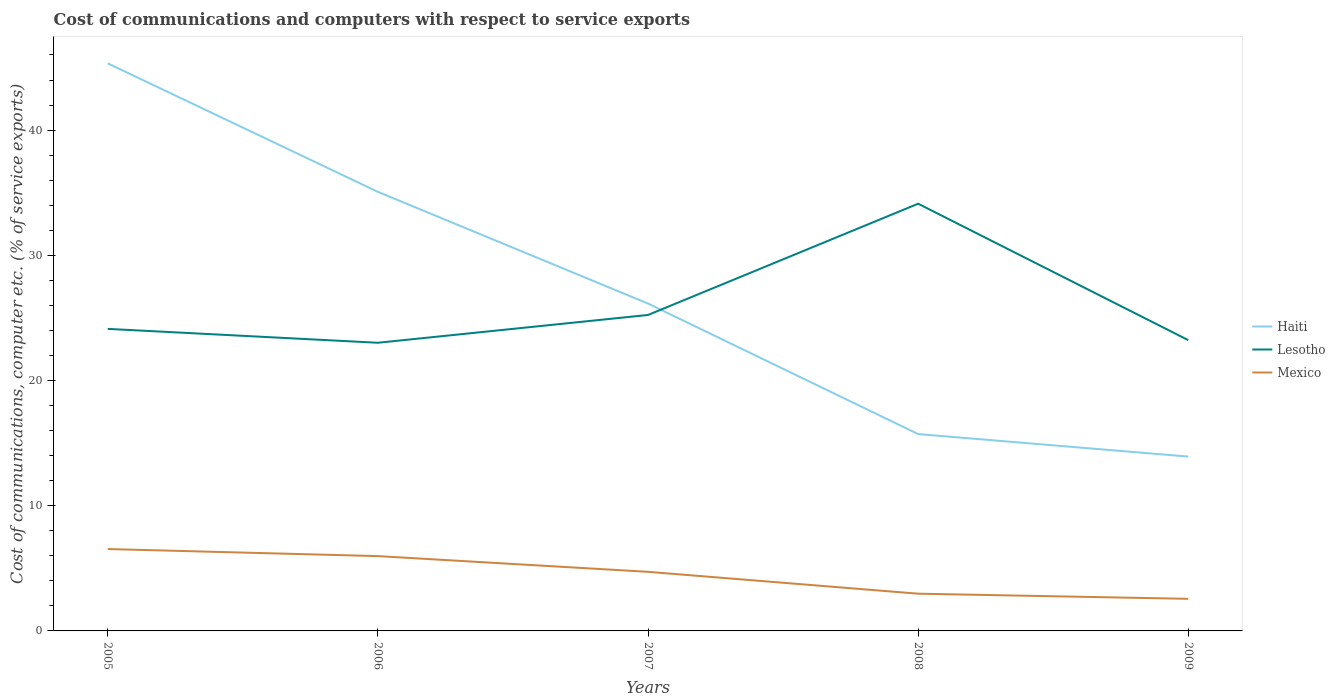Does the line corresponding to Mexico intersect with the line corresponding to Haiti?
Your answer should be very brief. No. Across all years, what is the maximum cost of communications and computers in Mexico?
Provide a short and direct response. 2.56. In which year was the cost of communications and computers in Mexico maximum?
Provide a short and direct response. 2009. What is the total cost of communications and computers in Haiti in the graph?
Give a very brief answer. 8.92. What is the difference between the highest and the second highest cost of communications and computers in Haiti?
Make the answer very short. 31.41. How many lines are there?
Offer a terse response. 3. What is the difference between two consecutive major ticks on the Y-axis?
Offer a very short reply. 10. Are the values on the major ticks of Y-axis written in scientific E-notation?
Give a very brief answer. No. Does the graph contain grids?
Your response must be concise. No. Where does the legend appear in the graph?
Provide a succinct answer. Center right. How many legend labels are there?
Your response must be concise. 3. What is the title of the graph?
Provide a succinct answer. Cost of communications and computers with respect to service exports. Does "Albania" appear as one of the legend labels in the graph?
Your answer should be compact. No. What is the label or title of the X-axis?
Make the answer very short. Years. What is the label or title of the Y-axis?
Make the answer very short. Cost of communications, computer etc. (% of service exports). What is the Cost of communications, computer etc. (% of service exports) in Haiti in 2005?
Your answer should be compact. 45.33. What is the Cost of communications, computer etc. (% of service exports) of Lesotho in 2005?
Provide a succinct answer. 24.12. What is the Cost of communications, computer etc. (% of service exports) of Mexico in 2005?
Provide a succinct answer. 6.54. What is the Cost of communications, computer etc. (% of service exports) in Haiti in 2006?
Ensure brevity in your answer.  35.07. What is the Cost of communications, computer etc. (% of service exports) in Lesotho in 2006?
Ensure brevity in your answer.  23.02. What is the Cost of communications, computer etc. (% of service exports) of Mexico in 2006?
Provide a short and direct response. 5.98. What is the Cost of communications, computer etc. (% of service exports) of Haiti in 2007?
Give a very brief answer. 26.15. What is the Cost of communications, computer etc. (% of service exports) in Lesotho in 2007?
Offer a terse response. 25.24. What is the Cost of communications, computer etc. (% of service exports) of Mexico in 2007?
Your answer should be compact. 4.72. What is the Cost of communications, computer etc. (% of service exports) in Haiti in 2008?
Your answer should be very brief. 15.72. What is the Cost of communications, computer etc. (% of service exports) of Lesotho in 2008?
Provide a short and direct response. 34.12. What is the Cost of communications, computer etc. (% of service exports) in Mexico in 2008?
Provide a short and direct response. 2.97. What is the Cost of communications, computer etc. (% of service exports) in Haiti in 2009?
Ensure brevity in your answer.  13.92. What is the Cost of communications, computer etc. (% of service exports) in Lesotho in 2009?
Offer a very short reply. 23.23. What is the Cost of communications, computer etc. (% of service exports) of Mexico in 2009?
Your answer should be compact. 2.56. Across all years, what is the maximum Cost of communications, computer etc. (% of service exports) in Haiti?
Offer a very short reply. 45.33. Across all years, what is the maximum Cost of communications, computer etc. (% of service exports) of Lesotho?
Give a very brief answer. 34.12. Across all years, what is the maximum Cost of communications, computer etc. (% of service exports) of Mexico?
Keep it short and to the point. 6.54. Across all years, what is the minimum Cost of communications, computer etc. (% of service exports) of Haiti?
Provide a succinct answer. 13.92. Across all years, what is the minimum Cost of communications, computer etc. (% of service exports) in Lesotho?
Provide a short and direct response. 23.02. Across all years, what is the minimum Cost of communications, computer etc. (% of service exports) of Mexico?
Offer a terse response. 2.56. What is the total Cost of communications, computer etc. (% of service exports) of Haiti in the graph?
Your answer should be compact. 136.2. What is the total Cost of communications, computer etc. (% of service exports) of Lesotho in the graph?
Make the answer very short. 129.72. What is the total Cost of communications, computer etc. (% of service exports) in Mexico in the graph?
Ensure brevity in your answer.  22.77. What is the difference between the Cost of communications, computer etc. (% of service exports) in Haiti in 2005 and that in 2006?
Make the answer very short. 10.26. What is the difference between the Cost of communications, computer etc. (% of service exports) of Lesotho in 2005 and that in 2006?
Your answer should be compact. 1.11. What is the difference between the Cost of communications, computer etc. (% of service exports) in Mexico in 2005 and that in 2006?
Offer a very short reply. 0.56. What is the difference between the Cost of communications, computer etc. (% of service exports) in Haiti in 2005 and that in 2007?
Offer a terse response. 19.18. What is the difference between the Cost of communications, computer etc. (% of service exports) of Lesotho in 2005 and that in 2007?
Provide a succinct answer. -1.11. What is the difference between the Cost of communications, computer etc. (% of service exports) in Mexico in 2005 and that in 2007?
Make the answer very short. 1.82. What is the difference between the Cost of communications, computer etc. (% of service exports) in Haiti in 2005 and that in 2008?
Provide a succinct answer. 29.61. What is the difference between the Cost of communications, computer etc. (% of service exports) of Lesotho in 2005 and that in 2008?
Offer a very short reply. -10. What is the difference between the Cost of communications, computer etc. (% of service exports) in Mexico in 2005 and that in 2008?
Offer a terse response. 3.57. What is the difference between the Cost of communications, computer etc. (% of service exports) in Haiti in 2005 and that in 2009?
Make the answer very short. 31.41. What is the difference between the Cost of communications, computer etc. (% of service exports) in Lesotho in 2005 and that in 2009?
Offer a very short reply. 0.9. What is the difference between the Cost of communications, computer etc. (% of service exports) in Mexico in 2005 and that in 2009?
Provide a succinct answer. 3.98. What is the difference between the Cost of communications, computer etc. (% of service exports) of Haiti in 2006 and that in 2007?
Your answer should be compact. 8.92. What is the difference between the Cost of communications, computer etc. (% of service exports) in Lesotho in 2006 and that in 2007?
Make the answer very short. -2.22. What is the difference between the Cost of communications, computer etc. (% of service exports) of Mexico in 2006 and that in 2007?
Your answer should be compact. 1.26. What is the difference between the Cost of communications, computer etc. (% of service exports) of Haiti in 2006 and that in 2008?
Your answer should be very brief. 19.35. What is the difference between the Cost of communications, computer etc. (% of service exports) in Lesotho in 2006 and that in 2008?
Provide a succinct answer. -11.11. What is the difference between the Cost of communications, computer etc. (% of service exports) of Mexico in 2006 and that in 2008?
Ensure brevity in your answer.  3. What is the difference between the Cost of communications, computer etc. (% of service exports) of Haiti in 2006 and that in 2009?
Your answer should be very brief. 21.14. What is the difference between the Cost of communications, computer etc. (% of service exports) in Lesotho in 2006 and that in 2009?
Provide a succinct answer. -0.21. What is the difference between the Cost of communications, computer etc. (% of service exports) in Mexico in 2006 and that in 2009?
Your response must be concise. 3.41. What is the difference between the Cost of communications, computer etc. (% of service exports) in Haiti in 2007 and that in 2008?
Your answer should be compact. 10.43. What is the difference between the Cost of communications, computer etc. (% of service exports) in Lesotho in 2007 and that in 2008?
Make the answer very short. -8.89. What is the difference between the Cost of communications, computer etc. (% of service exports) of Mexico in 2007 and that in 2008?
Offer a terse response. 1.75. What is the difference between the Cost of communications, computer etc. (% of service exports) in Haiti in 2007 and that in 2009?
Your answer should be compact. 12.22. What is the difference between the Cost of communications, computer etc. (% of service exports) in Lesotho in 2007 and that in 2009?
Provide a short and direct response. 2.01. What is the difference between the Cost of communications, computer etc. (% of service exports) of Mexico in 2007 and that in 2009?
Ensure brevity in your answer.  2.16. What is the difference between the Cost of communications, computer etc. (% of service exports) in Haiti in 2008 and that in 2009?
Keep it short and to the point. 1.8. What is the difference between the Cost of communications, computer etc. (% of service exports) in Lesotho in 2008 and that in 2009?
Your answer should be very brief. 10.9. What is the difference between the Cost of communications, computer etc. (% of service exports) in Mexico in 2008 and that in 2009?
Offer a very short reply. 0.41. What is the difference between the Cost of communications, computer etc. (% of service exports) of Haiti in 2005 and the Cost of communications, computer etc. (% of service exports) of Lesotho in 2006?
Ensure brevity in your answer.  22.32. What is the difference between the Cost of communications, computer etc. (% of service exports) in Haiti in 2005 and the Cost of communications, computer etc. (% of service exports) in Mexico in 2006?
Offer a terse response. 39.36. What is the difference between the Cost of communications, computer etc. (% of service exports) of Lesotho in 2005 and the Cost of communications, computer etc. (% of service exports) of Mexico in 2006?
Provide a short and direct response. 18.15. What is the difference between the Cost of communications, computer etc. (% of service exports) in Haiti in 2005 and the Cost of communications, computer etc. (% of service exports) in Lesotho in 2007?
Your response must be concise. 20.1. What is the difference between the Cost of communications, computer etc. (% of service exports) in Haiti in 2005 and the Cost of communications, computer etc. (% of service exports) in Mexico in 2007?
Provide a short and direct response. 40.61. What is the difference between the Cost of communications, computer etc. (% of service exports) of Lesotho in 2005 and the Cost of communications, computer etc. (% of service exports) of Mexico in 2007?
Provide a short and direct response. 19.4. What is the difference between the Cost of communications, computer etc. (% of service exports) of Haiti in 2005 and the Cost of communications, computer etc. (% of service exports) of Lesotho in 2008?
Keep it short and to the point. 11.21. What is the difference between the Cost of communications, computer etc. (% of service exports) of Haiti in 2005 and the Cost of communications, computer etc. (% of service exports) of Mexico in 2008?
Offer a very short reply. 42.36. What is the difference between the Cost of communications, computer etc. (% of service exports) in Lesotho in 2005 and the Cost of communications, computer etc. (% of service exports) in Mexico in 2008?
Make the answer very short. 21.15. What is the difference between the Cost of communications, computer etc. (% of service exports) in Haiti in 2005 and the Cost of communications, computer etc. (% of service exports) in Lesotho in 2009?
Provide a succinct answer. 22.11. What is the difference between the Cost of communications, computer etc. (% of service exports) in Haiti in 2005 and the Cost of communications, computer etc. (% of service exports) in Mexico in 2009?
Make the answer very short. 42.77. What is the difference between the Cost of communications, computer etc. (% of service exports) of Lesotho in 2005 and the Cost of communications, computer etc. (% of service exports) of Mexico in 2009?
Your answer should be compact. 21.56. What is the difference between the Cost of communications, computer etc. (% of service exports) of Haiti in 2006 and the Cost of communications, computer etc. (% of service exports) of Lesotho in 2007?
Ensure brevity in your answer.  9.83. What is the difference between the Cost of communications, computer etc. (% of service exports) of Haiti in 2006 and the Cost of communications, computer etc. (% of service exports) of Mexico in 2007?
Provide a succinct answer. 30.35. What is the difference between the Cost of communications, computer etc. (% of service exports) in Lesotho in 2006 and the Cost of communications, computer etc. (% of service exports) in Mexico in 2007?
Give a very brief answer. 18.3. What is the difference between the Cost of communications, computer etc. (% of service exports) of Haiti in 2006 and the Cost of communications, computer etc. (% of service exports) of Lesotho in 2008?
Provide a succinct answer. 0.95. What is the difference between the Cost of communications, computer etc. (% of service exports) in Haiti in 2006 and the Cost of communications, computer etc. (% of service exports) in Mexico in 2008?
Your response must be concise. 32.1. What is the difference between the Cost of communications, computer etc. (% of service exports) of Lesotho in 2006 and the Cost of communications, computer etc. (% of service exports) of Mexico in 2008?
Your answer should be very brief. 20.04. What is the difference between the Cost of communications, computer etc. (% of service exports) in Haiti in 2006 and the Cost of communications, computer etc. (% of service exports) in Lesotho in 2009?
Your response must be concise. 11.84. What is the difference between the Cost of communications, computer etc. (% of service exports) of Haiti in 2006 and the Cost of communications, computer etc. (% of service exports) of Mexico in 2009?
Keep it short and to the point. 32.51. What is the difference between the Cost of communications, computer etc. (% of service exports) of Lesotho in 2006 and the Cost of communications, computer etc. (% of service exports) of Mexico in 2009?
Your answer should be very brief. 20.45. What is the difference between the Cost of communications, computer etc. (% of service exports) of Haiti in 2007 and the Cost of communications, computer etc. (% of service exports) of Lesotho in 2008?
Offer a very short reply. -7.97. What is the difference between the Cost of communications, computer etc. (% of service exports) in Haiti in 2007 and the Cost of communications, computer etc. (% of service exports) in Mexico in 2008?
Give a very brief answer. 23.17. What is the difference between the Cost of communications, computer etc. (% of service exports) in Lesotho in 2007 and the Cost of communications, computer etc. (% of service exports) in Mexico in 2008?
Your answer should be compact. 22.26. What is the difference between the Cost of communications, computer etc. (% of service exports) of Haiti in 2007 and the Cost of communications, computer etc. (% of service exports) of Lesotho in 2009?
Give a very brief answer. 2.92. What is the difference between the Cost of communications, computer etc. (% of service exports) in Haiti in 2007 and the Cost of communications, computer etc. (% of service exports) in Mexico in 2009?
Offer a terse response. 23.59. What is the difference between the Cost of communications, computer etc. (% of service exports) of Lesotho in 2007 and the Cost of communications, computer etc. (% of service exports) of Mexico in 2009?
Give a very brief answer. 22.67. What is the difference between the Cost of communications, computer etc. (% of service exports) in Haiti in 2008 and the Cost of communications, computer etc. (% of service exports) in Lesotho in 2009?
Your answer should be very brief. -7.5. What is the difference between the Cost of communications, computer etc. (% of service exports) of Haiti in 2008 and the Cost of communications, computer etc. (% of service exports) of Mexico in 2009?
Keep it short and to the point. 13.16. What is the difference between the Cost of communications, computer etc. (% of service exports) in Lesotho in 2008 and the Cost of communications, computer etc. (% of service exports) in Mexico in 2009?
Your response must be concise. 31.56. What is the average Cost of communications, computer etc. (% of service exports) of Haiti per year?
Ensure brevity in your answer.  27.24. What is the average Cost of communications, computer etc. (% of service exports) in Lesotho per year?
Ensure brevity in your answer.  25.94. What is the average Cost of communications, computer etc. (% of service exports) of Mexico per year?
Your response must be concise. 4.55. In the year 2005, what is the difference between the Cost of communications, computer etc. (% of service exports) in Haiti and Cost of communications, computer etc. (% of service exports) in Lesotho?
Provide a short and direct response. 21.21. In the year 2005, what is the difference between the Cost of communications, computer etc. (% of service exports) in Haiti and Cost of communications, computer etc. (% of service exports) in Mexico?
Make the answer very short. 38.79. In the year 2005, what is the difference between the Cost of communications, computer etc. (% of service exports) in Lesotho and Cost of communications, computer etc. (% of service exports) in Mexico?
Your answer should be compact. 17.58. In the year 2006, what is the difference between the Cost of communications, computer etc. (% of service exports) in Haiti and Cost of communications, computer etc. (% of service exports) in Lesotho?
Provide a succinct answer. 12.05. In the year 2006, what is the difference between the Cost of communications, computer etc. (% of service exports) in Haiti and Cost of communications, computer etc. (% of service exports) in Mexico?
Provide a succinct answer. 29.09. In the year 2006, what is the difference between the Cost of communications, computer etc. (% of service exports) in Lesotho and Cost of communications, computer etc. (% of service exports) in Mexico?
Offer a terse response. 17.04. In the year 2007, what is the difference between the Cost of communications, computer etc. (% of service exports) of Haiti and Cost of communications, computer etc. (% of service exports) of Lesotho?
Make the answer very short. 0.91. In the year 2007, what is the difference between the Cost of communications, computer etc. (% of service exports) in Haiti and Cost of communications, computer etc. (% of service exports) in Mexico?
Provide a succinct answer. 21.43. In the year 2007, what is the difference between the Cost of communications, computer etc. (% of service exports) in Lesotho and Cost of communications, computer etc. (% of service exports) in Mexico?
Offer a terse response. 20.52. In the year 2008, what is the difference between the Cost of communications, computer etc. (% of service exports) of Haiti and Cost of communications, computer etc. (% of service exports) of Lesotho?
Your answer should be very brief. -18.4. In the year 2008, what is the difference between the Cost of communications, computer etc. (% of service exports) in Haiti and Cost of communications, computer etc. (% of service exports) in Mexico?
Make the answer very short. 12.75. In the year 2008, what is the difference between the Cost of communications, computer etc. (% of service exports) of Lesotho and Cost of communications, computer etc. (% of service exports) of Mexico?
Ensure brevity in your answer.  31.15. In the year 2009, what is the difference between the Cost of communications, computer etc. (% of service exports) of Haiti and Cost of communications, computer etc. (% of service exports) of Lesotho?
Offer a very short reply. -9.3. In the year 2009, what is the difference between the Cost of communications, computer etc. (% of service exports) of Haiti and Cost of communications, computer etc. (% of service exports) of Mexico?
Ensure brevity in your answer.  11.36. In the year 2009, what is the difference between the Cost of communications, computer etc. (% of service exports) of Lesotho and Cost of communications, computer etc. (% of service exports) of Mexico?
Offer a terse response. 20.66. What is the ratio of the Cost of communications, computer etc. (% of service exports) of Haiti in 2005 to that in 2006?
Your answer should be compact. 1.29. What is the ratio of the Cost of communications, computer etc. (% of service exports) in Lesotho in 2005 to that in 2006?
Offer a very short reply. 1.05. What is the ratio of the Cost of communications, computer etc. (% of service exports) of Mexico in 2005 to that in 2006?
Keep it short and to the point. 1.09. What is the ratio of the Cost of communications, computer etc. (% of service exports) in Haiti in 2005 to that in 2007?
Make the answer very short. 1.73. What is the ratio of the Cost of communications, computer etc. (% of service exports) of Lesotho in 2005 to that in 2007?
Your response must be concise. 0.96. What is the ratio of the Cost of communications, computer etc. (% of service exports) in Mexico in 2005 to that in 2007?
Offer a very short reply. 1.39. What is the ratio of the Cost of communications, computer etc. (% of service exports) of Haiti in 2005 to that in 2008?
Offer a very short reply. 2.88. What is the ratio of the Cost of communications, computer etc. (% of service exports) in Lesotho in 2005 to that in 2008?
Give a very brief answer. 0.71. What is the ratio of the Cost of communications, computer etc. (% of service exports) in Mexico in 2005 to that in 2008?
Make the answer very short. 2.2. What is the ratio of the Cost of communications, computer etc. (% of service exports) of Haiti in 2005 to that in 2009?
Your response must be concise. 3.26. What is the ratio of the Cost of communications, computer etc. (% of service exports) of Lesotho in 2005 to that in 2009?
Keep it short and to the point. 1.04. What is the ratio of the Cost of communications, computer etc. (% of service exports) of Mexico in 2005 to that in 2009?
Offer a very short reply. 2.55. What is the ratio of the Cost of communications, computer etc. (% of service exports) in Haiti in 2006 to that in 2007?
Make the answer very short. 1.34. What is the ratio of the Cost of communications, computer etc. (% of service exports) of Lesotho in 2006 to that in 2007?
Provide a short and direct response. 0.91. What is the ratio of the Cost of communications, computer etc. (% of service exports) of Mexico in 2006 to that in 2007?
Keep it short and to the point. 1.27. What is the ratio of the Cost of communications, computer etc. (% of service exports) of Haiti in 2006 to that in 2008?
Your response must be concise. 2.23. What is the ratio of the Cost of communications, computer etc. (% of service exports) in Lesotho in 2006 to that in 2008?
Provide a succinct answer. 0.67. What is the ratio of the Cost of communications, computer etc. (% of service exports) of Mexico in 2006 to that in 2008?
Keep it short and to the point. 2.01. What is the ratio of the Cost of communications, computer etc. (% of service exports) in Haiti in 2006 to that in 2009?
Your answer should be very brief. 2.52. What is the ratio of the Cost of communications, computer etc. (% of service exports) in Mexico in 2006 to that in 2009?
Make the answer very short. 2.33. What is the ratio of the Cost of communications, computer etc. (% of service exports) in Haiti in 2007 to that in 2008?
Provide a succinct answer. 1.66. What is the ratio of the Cost of communications, computer etc. (% of service exports) in Lesotho in 2007 to that in 2008?
Your answer should be compact. 0.74. What is the ratio of the Cost of communications, computer etc. (% of service exports) in Mexico in 2007 to that in 2008?
Make the answer very short. 1.59. What is the ratio of the Cost of communications, computer etc. (% of service exports) in Haiti in 2007 to that in 2009?
Offer a very short reply. 1.88. What is the ratio of the Cost of communications, computer etc. (% of service exports) in Lesotho in 2007 to that in 2009?
Your response must be concise. 1.09. What is the ratio of the Cost of communications, computer etc. (% of service exports) in Mexico in 2007 to that in 2009?
Offer a very short reply. 1.84. What is the ratio of the Cost of communications, computer etc. (% of service exports) in Haiti in 2008 to that in 2009?
Your answer should be very brief. 1.13. What is the ratio of the Cost of communications, computer etc. (% of service exports) of Lesotho in 2008 to that in 2009?
Give a very brief answer. 1.47. What is the ratio of the Cost of communications, computer etc. (% of service exports) of Mexico in 2008 to that in 2009?
Offer a terse response. 1.16. What is the difference between the highest and the second highest Cost of communications, computer etc. (% of service exports) of Haiti?
Your answer should be very brief. 10.26. What is the difference between the highest and the second highest Cost of communications, computer etc. (% of service exports) of Lesotho?
Ensure brevity in your answer.  8.89. What is the difference between the highest and the second highest Cost of communications, computer etc. (% of service exports) in Mexico?
Your answer should be compact. 0.56. What is the difference between the highest and the lowest Cost of communications, computer etc. (% of service exports) in Haiti?
Your answer should be compact. 31.41. What is the difference between the highest and the lowest Cost of communications, computer etc. (% of service exports) in Lesotho?
Offer a very short reply. 11.11. What is the difference between the highest and the lowest Cost of communications, computer etc. (% of service exports) in Mexico?
Keep it short and to the point. 3.98. 